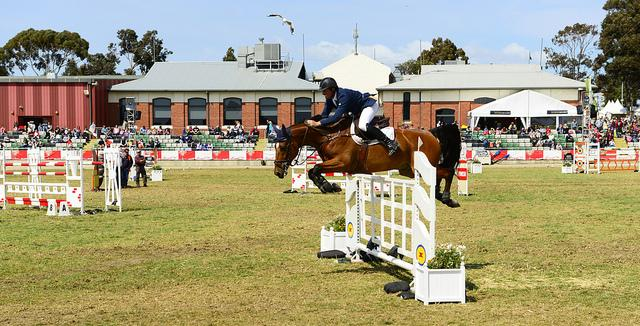What is the horse doing? Please explain your reasoning. leaping. The horse is leaping over a white fence because it is competing in an equestrian event. 